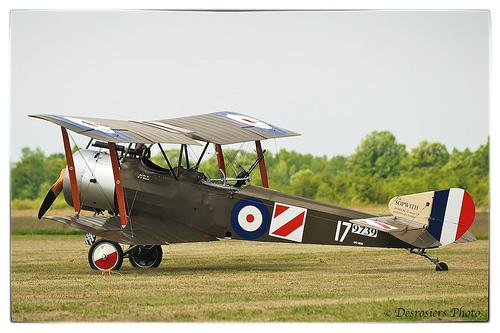Provide a brief description of the environment in which the plane is located. The plane is parked in a grassy area with some trees in the background and a hazy sky above. How many wheels does the plane have, and what is unique about the front wheel's appearance? The plane has 3 wheels, with the front wheel featuring red and white colors. Count and describe the wheels featured in the image along with their color. There are 3 wheels in total - a black tire, a red and white wheel on the plane, and one with a red and white center. What type of plane is in the image and what is its id number? It is a single engine World War I airplane with the id number 17 9739. What is the sentiment associated with the restored vintage airplane in the image? The sentiment is nostalgic and appreciative for its historical significance and the effort put into its restoration. Identify the color of the plane and the specific colors on the tail. The plane is gray, and the tail has red, white, and blue stripes painted on it. Explain the condition of the plane and its readiness for a potential flight. The plane appears well-maintained, clean, and painted, as if it's ready for a flight. Describe the appearance of the propeller on the airplane. The propeller is orange and black in color and is located at the front of the plane. What are the colors of the target on the airplane and describe the arrangement of the colors? The target is blue, white, and red, with a red dot in the center, a white ring around it, and a blue ring surrounding the white one. 